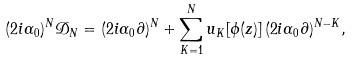Convert formula to latex. <formula><loc_0><loc_0><loc_500><loc_500>( 2 i \alpha _ { 0 } ) ^ { N } \mathcal { D } _ { N } = ( 2 i \alpha _ { 0 } \partial ) ^ { N } + \sum _ { K = 1 } ^ { N } u _ { K } [ \phi ( z ) ] \, ( 2 i \alpha _ { 0 } \partial ) ^ { N - K } ,</formula> 